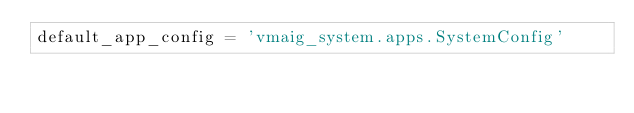<code> <loc_0><loc_0><loc_500><loc_500><_Python_>default_app_config = 'vmaig_system.apps.SystemConfig'</code> 